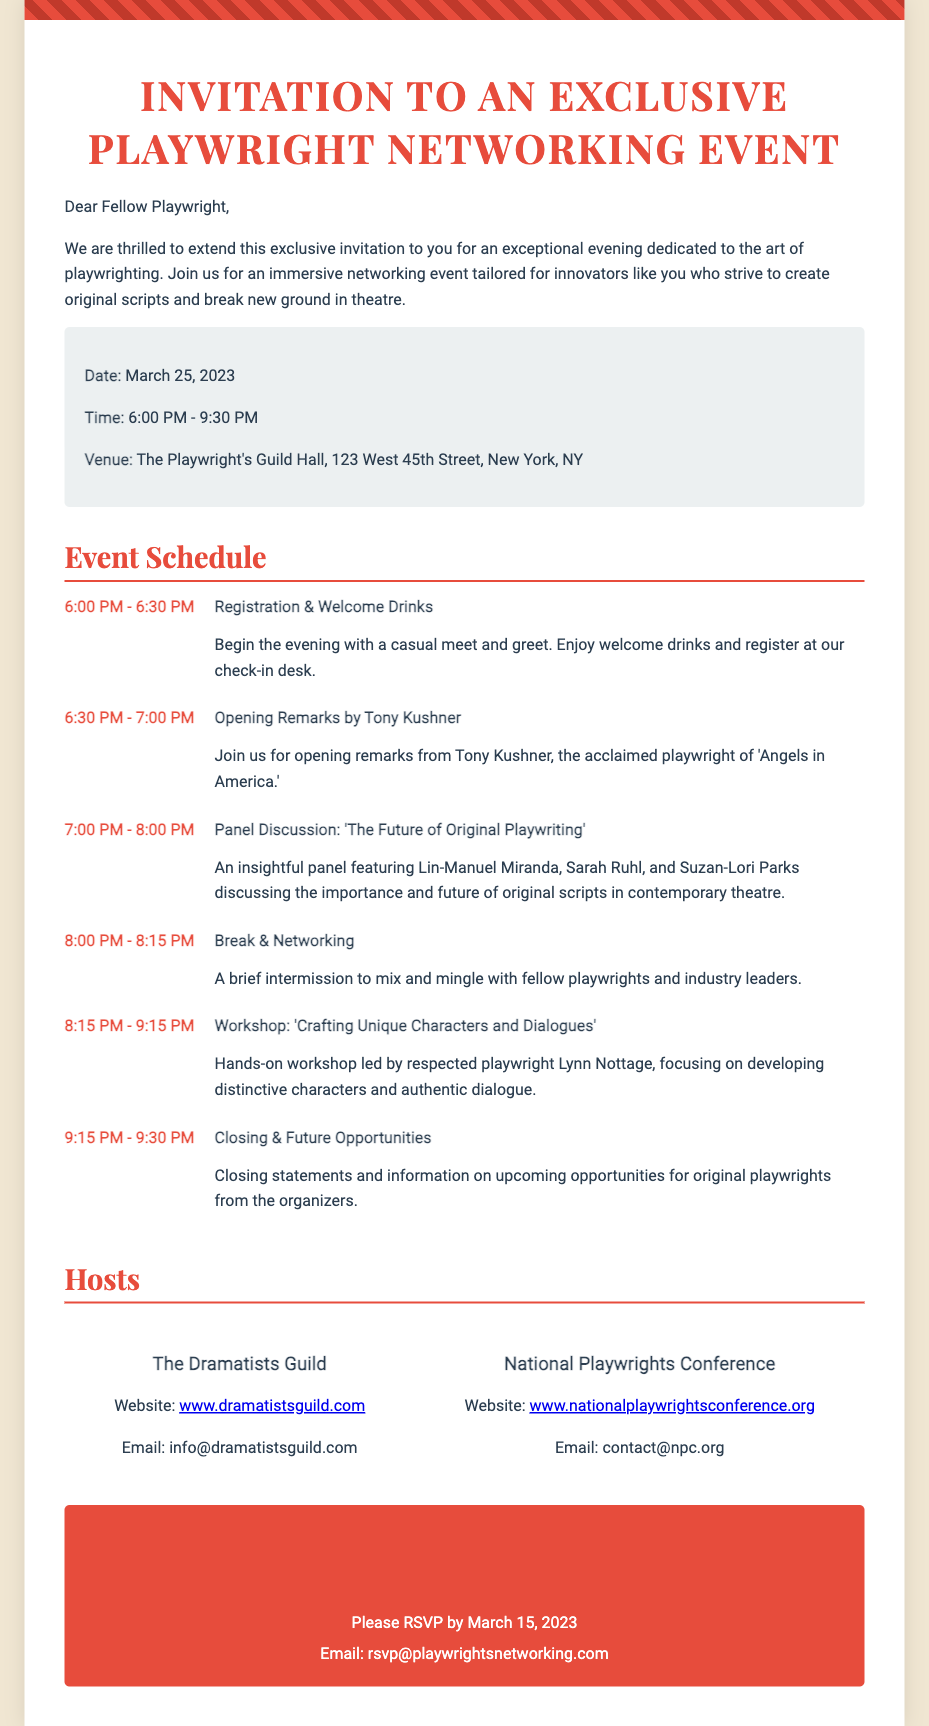What is the date of the event? The date of the event is specified in the document under "Event Details."
Answer: March 25, 2023 Who is delivering the opening remarks? The opening remarks are provided by a well-known playwright mentioned in the schedule.
Answer: Tony Kushner What time does the networking break start? The time for the networking break is mentioned in the schedule section of the document.
Answer: 8:00 PM What is the title of the workshop? The title of the workshop is given in the schedule and focuses on character development.
Answer: Crafting Unique Characters and Dialogues How many industry leaders are featured in the panel discussion? The number of leaders participating in the panel discussion can be found in the details of the schedule.
Answer: Three What is the RSVP deadline? The RSVP deadline is stated in the RSVP section of the document.
Answer: March 15, 2023 Which two organizations are hosting the event? The names of the hosting organizations are listed under the Hosts section of the invitation.
Answer: The Dramatists Guild and National Playwrights Conference What venue is hosting the event? The venue is clearly mentioned in the Event Details section of the document.
Answer: The Playwright's Guild Hall 